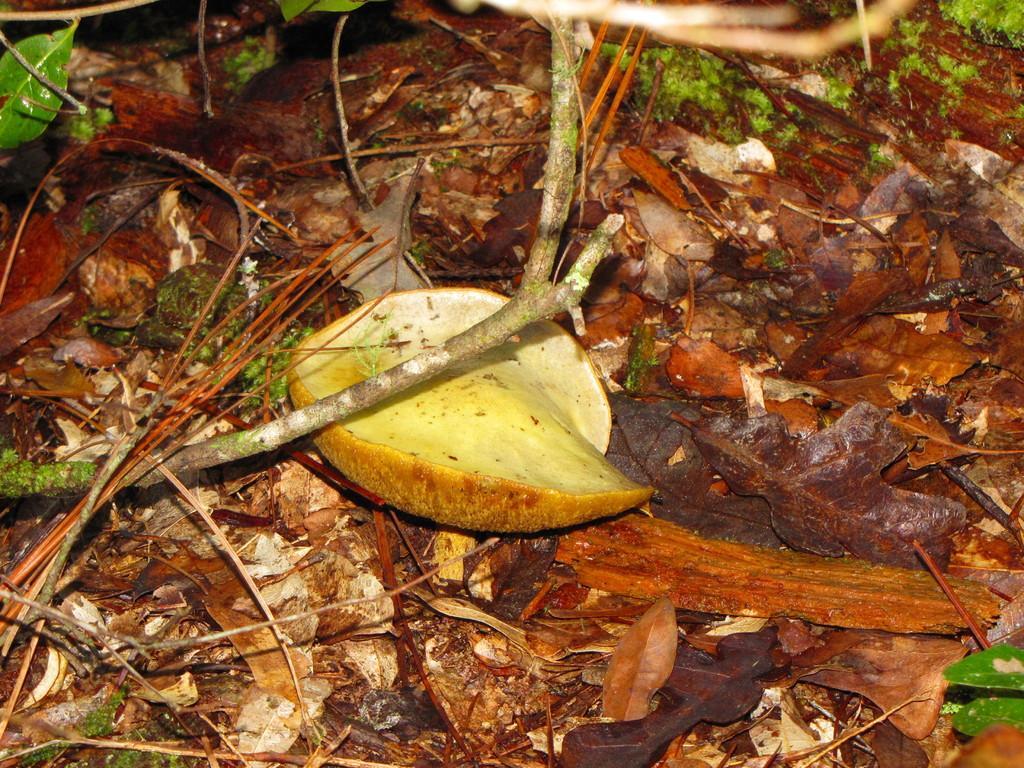Describe this image in one or two sentences. In this image in the foreground there are dry leaves, sticks, may be a fruit piece visible. 